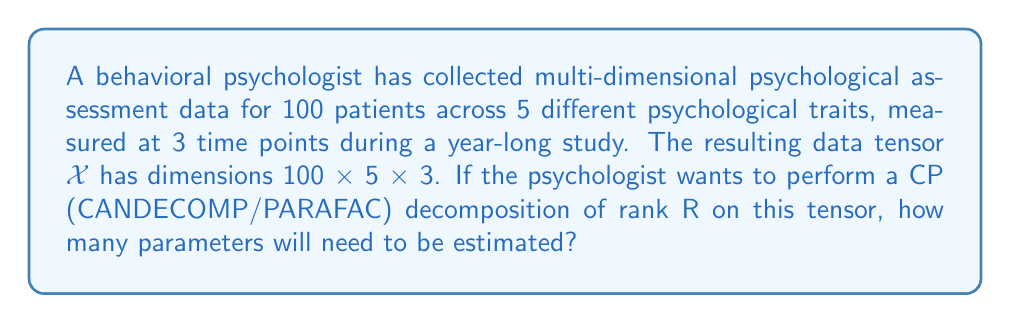What is the answer to this math problem? To solve this problem, we need to understand the structure of CP decomposition and count the number of parameters:

1) The CP decomposition of rank R for a 3-way tensor $\mathcal{X} \in \mathbb{R}^{I \times J \times K}$ is given by:

   $$\mathcal{X} \approx \sum_{r=1}^R a_r \circ b_r \circ c_r$$

   where $\circ$ denotes the outer product, and $a_r \in \mathbb{R}^I$, $b_r \in \mathbb{R}^J$, and $c_r \in \mathbb{R}^K$ are factor vectors.

2) In our case:
   - I = 100 (patients)
   - J = 5 (psychological traits)
   - K = 3 (time points)

3) For each rank r (from 1 to R), we need to estimate:
   - 100 parameters for $a_r$
   - 5 parameters for $b_r$
   - 3 parameters for $c_r$

4) The total number of parameters for one rank is:
   100 + 5 + 3 = 108

5) Since we're doing this for R ranks, the total number of parameters is:
   108 * R

Therefore, the number of parameters to be estimated in the CP decomposition of rank R for this tensor is 108R.
Answer: 108R 